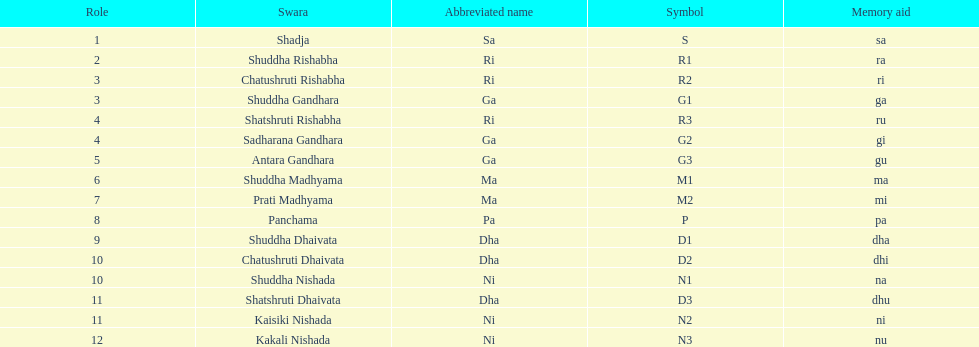What is the appellation of the swara succeeding panchama? Shuddha Dhaivata. 